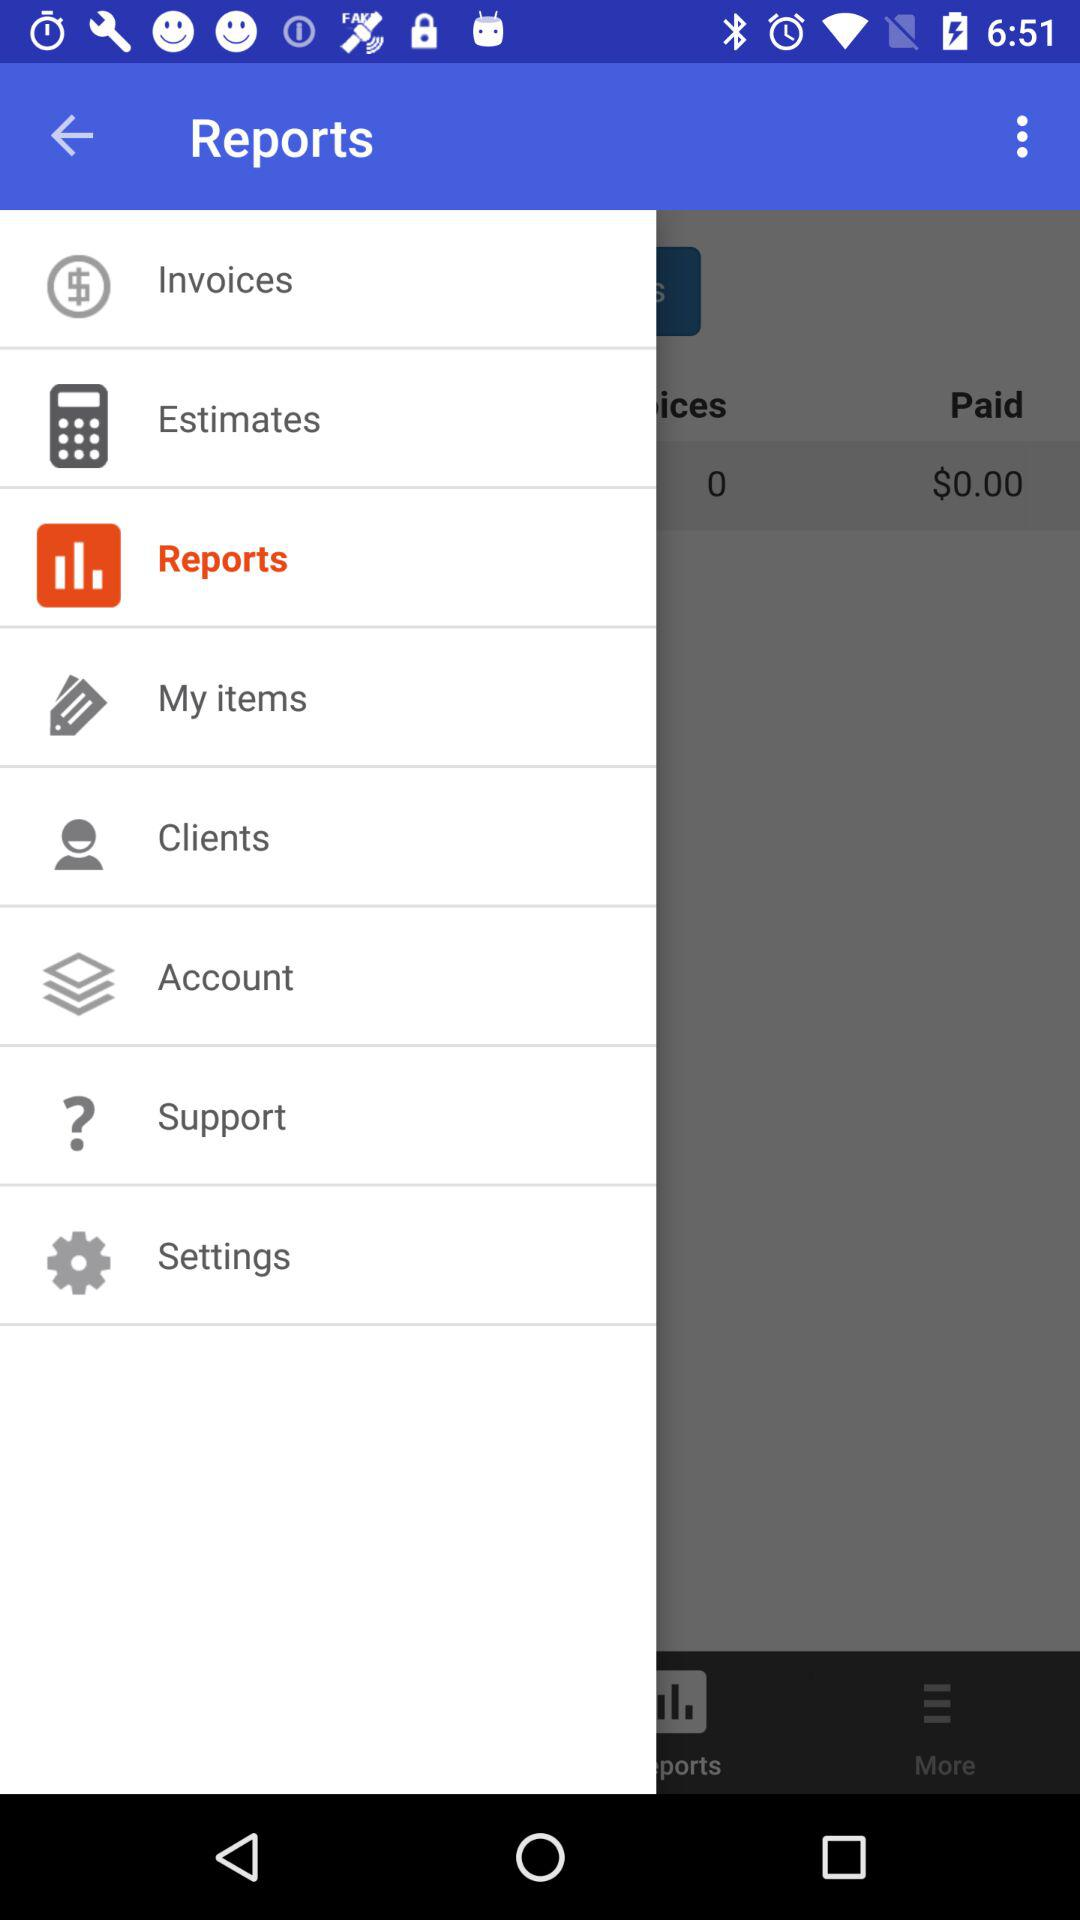What is the total amount of money due?
Answer the question using a single word or phrase. $0.00 